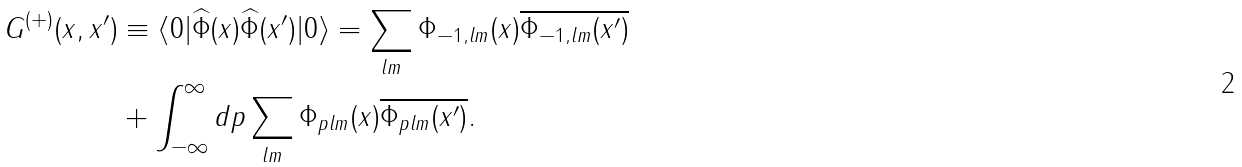<formula> <loc_0><loc_0><loc_500><loc_500>G ^ { ( + ) } ( x , x ^ { \prime } ) & \equiv \langle 0 | \widehat { \Phi } ( x ) \widehat { \Phi } ( x ^ { \prime } ) | 0 \rangle = \sum _ { l m } \Phi _ { - 1 , l m } ( x ) \overline { \Phi _ { - 1 , l m } ( x ^ { \prime } ) } \\ & + \int _ { - \infty } ^ { \infty } d p \sum _ { l m } \Phi _ { p l m } ( x ) \overline { \Phi _ { p l m } ( x ^ { \prime } ) } .</formula> 